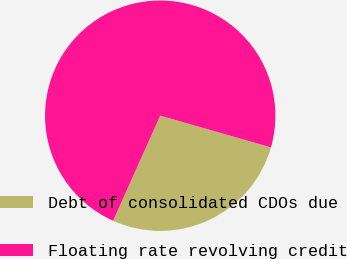<chart> <loc_0><loc_0><loc_500><loc_500><pie_chart><fcel>Debt of consolidated CDOs due<fcel>Floating rate revolving credit<nl><fcel>27.27%<fcel>72.73%<nl></chart> 